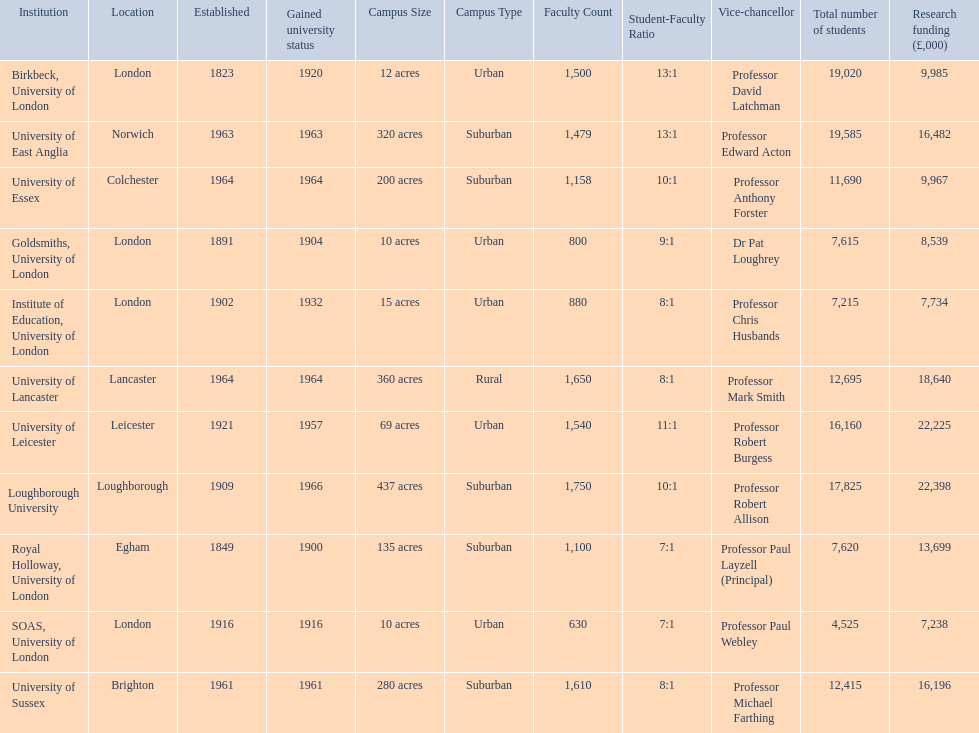Where is birbeck,university of london located? London. Which university was established in 1921? University of Leicester. Which institution gained university status recently? Loughborough University. 